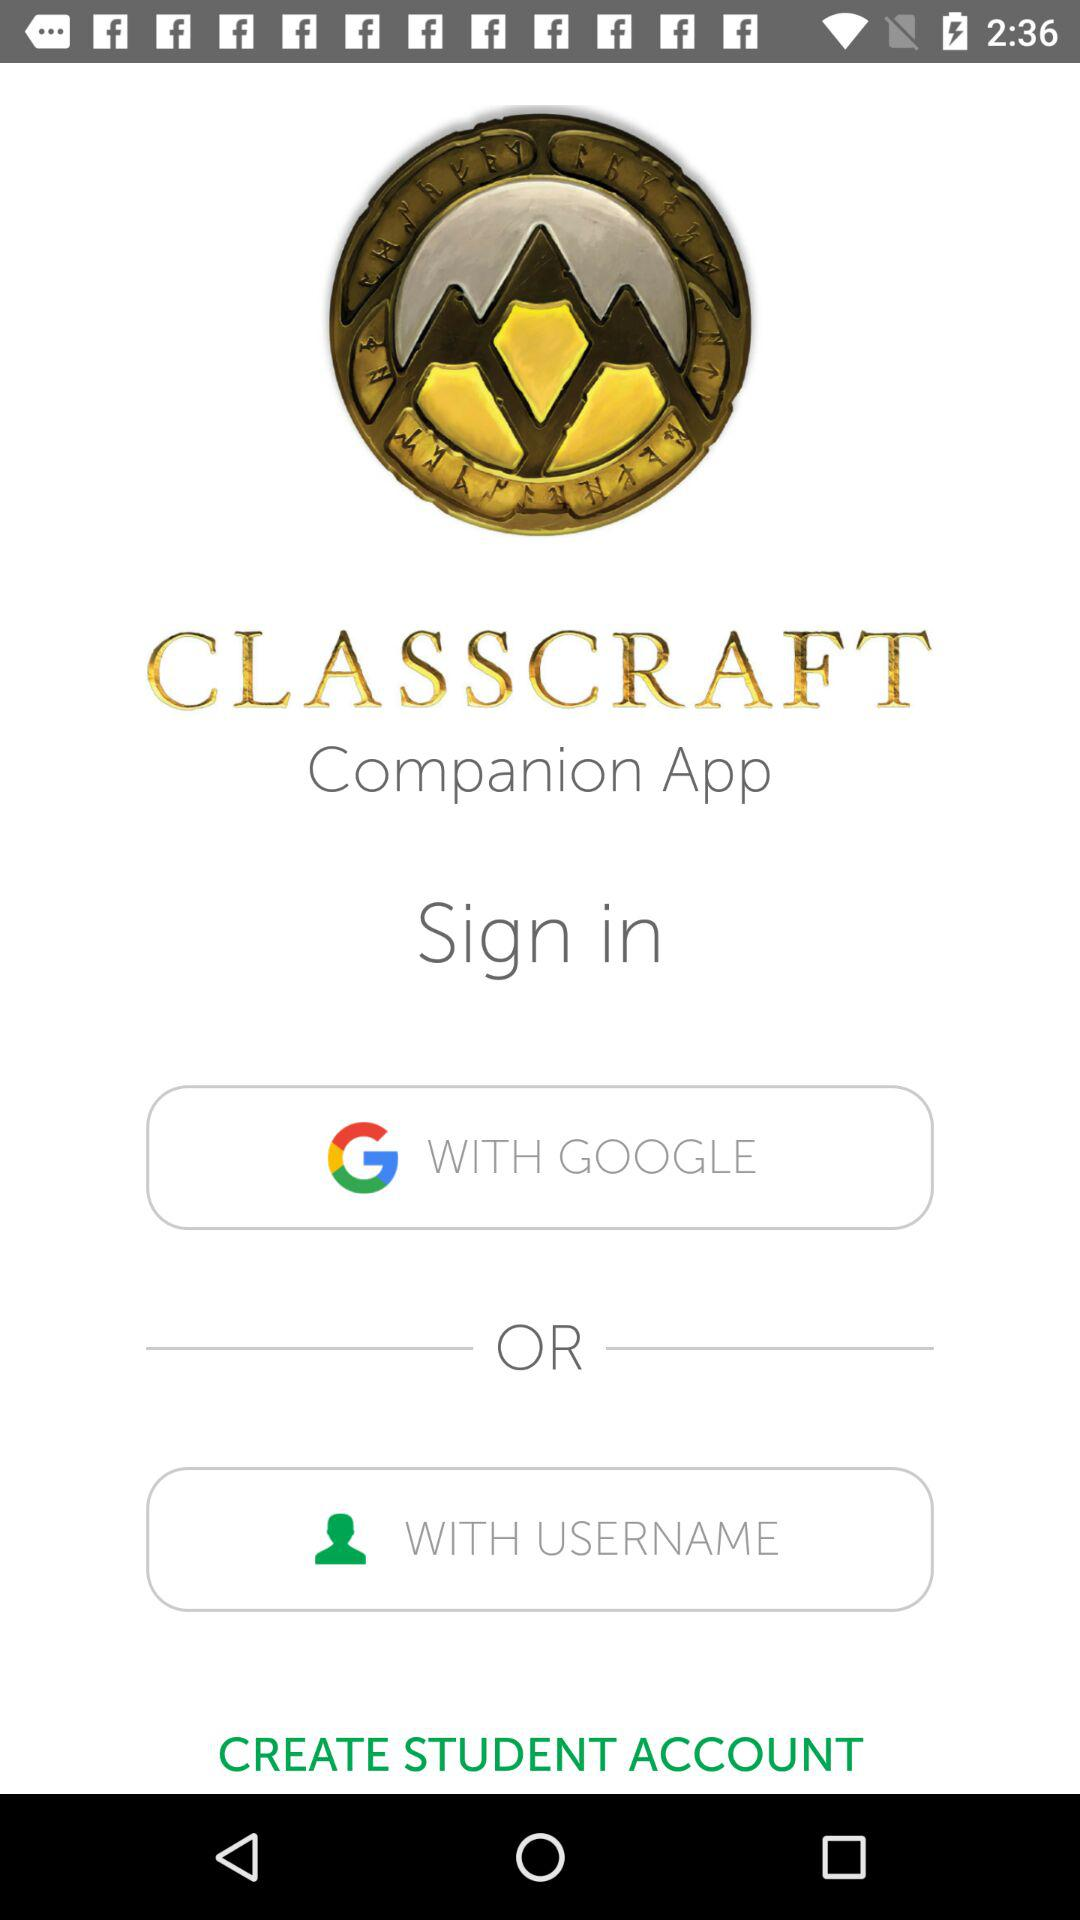What application can I choose to sign in? You can choose the "GOOGLE" application to sign in. 